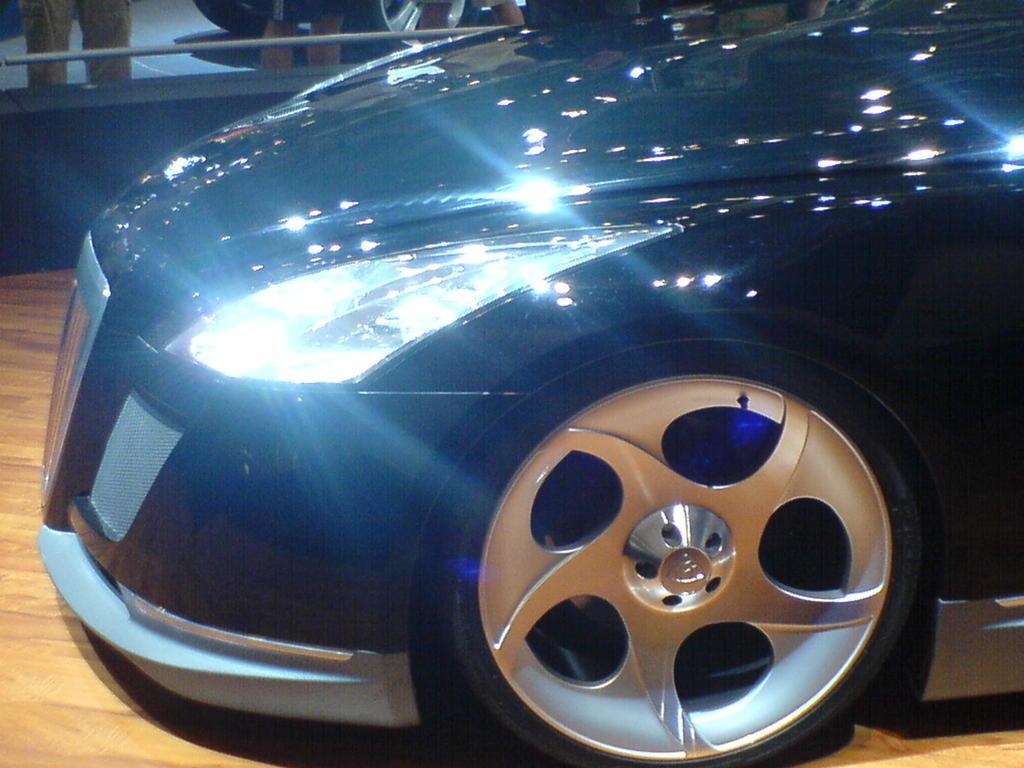Can you describe this image briefly? In this picture we can see a vehicle on the surface. In the background of the image we can see wall, rod, legs of people and wheels of a vehicle. 